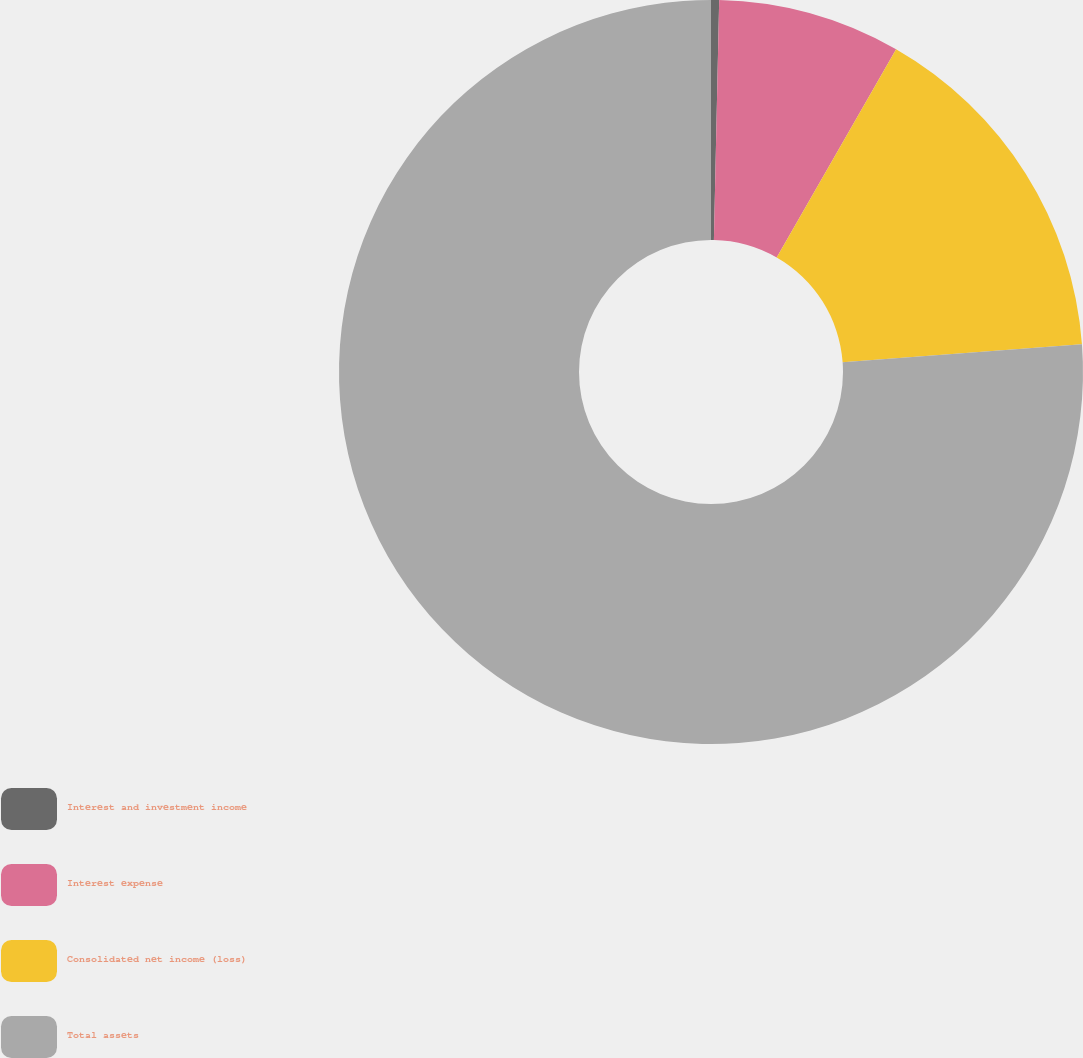<chart> <loc_0><loc_0><loc_500><loc_500><pie_chart><fcel>Interest and investment income<fcel>Interest expense<fcel>Consolidated net income (loss)<fcel>Total assets<nl><fcel>0.35%<fcel>7.94%<fcel>15.52%<fcel>76.19%<nl></chart> 